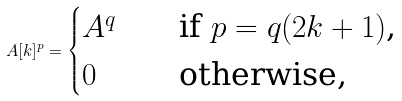<formula> <loc_0><loc_0><loc_500><loc_500>A [ k ] ^ { p } = \begin{cases} A ^ { q } & \quad \text {if $p=q(2k+1)$,} \\ 0 & \quad \text {otherwise,} \end{cases}</formula> 